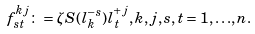<formula> <loc_0><loc_0><loc_500><loc_500>f ^ { k j } _ { s t } \colon = \zeta S ( l ^ { - s } _ { k } ) l ^ { + j } _ { t } , k , j , s , t = 1 , { \dots } , n .</formula> 